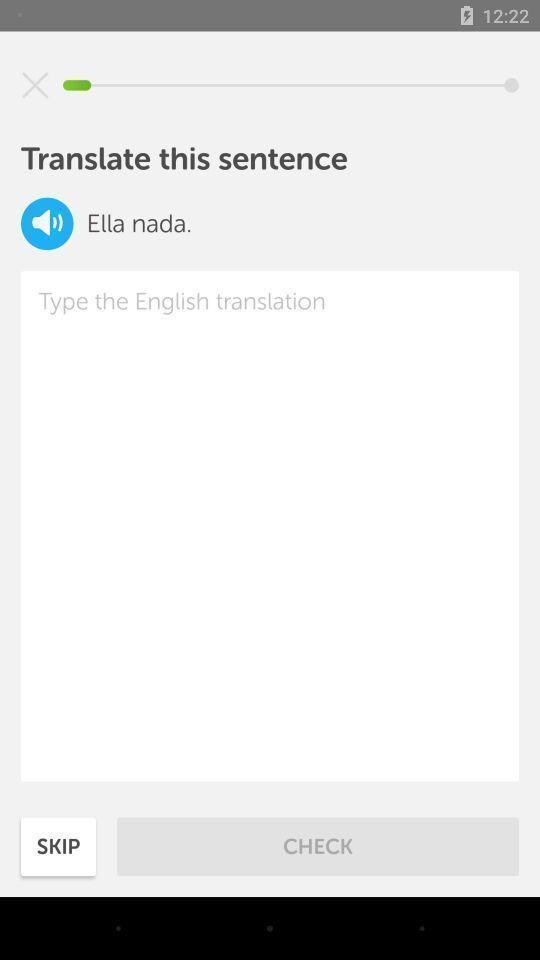Provide a textual representation of this image. Page showing option to translate text. 